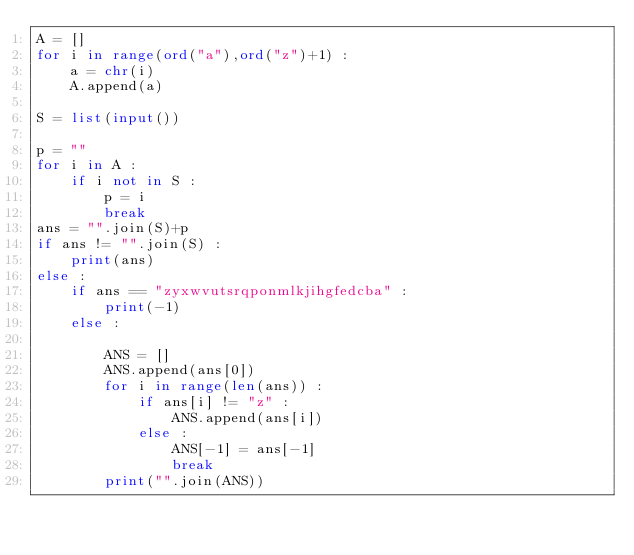Convert code to text. <code><loc_0><loc_0><loc_500><loc_500><_Python_>A = []
for i in range(ord("a"),ord("z")+1) :
    a = chr(i)
    A.append(a)

S = list(input())

p = ""
for i in A :
    if i not in S :
        p = i
        break
ans = "".join(S)+p
if ans != "".join(S) :
    print(ans)
else :
    if ans == "zyxwvutsrqponmlkjihgfedcba" :
        print(-1)
    else :
        
        ANS = []
        ANS.append(ans[0])
        for i in range(len(ans)) :
            if ans[i] != "z" :
                ANS.append(ans[i])
            else :
                ANS[-1] = ans[-1]
                break
        print("".join(ANS))
        </code> 